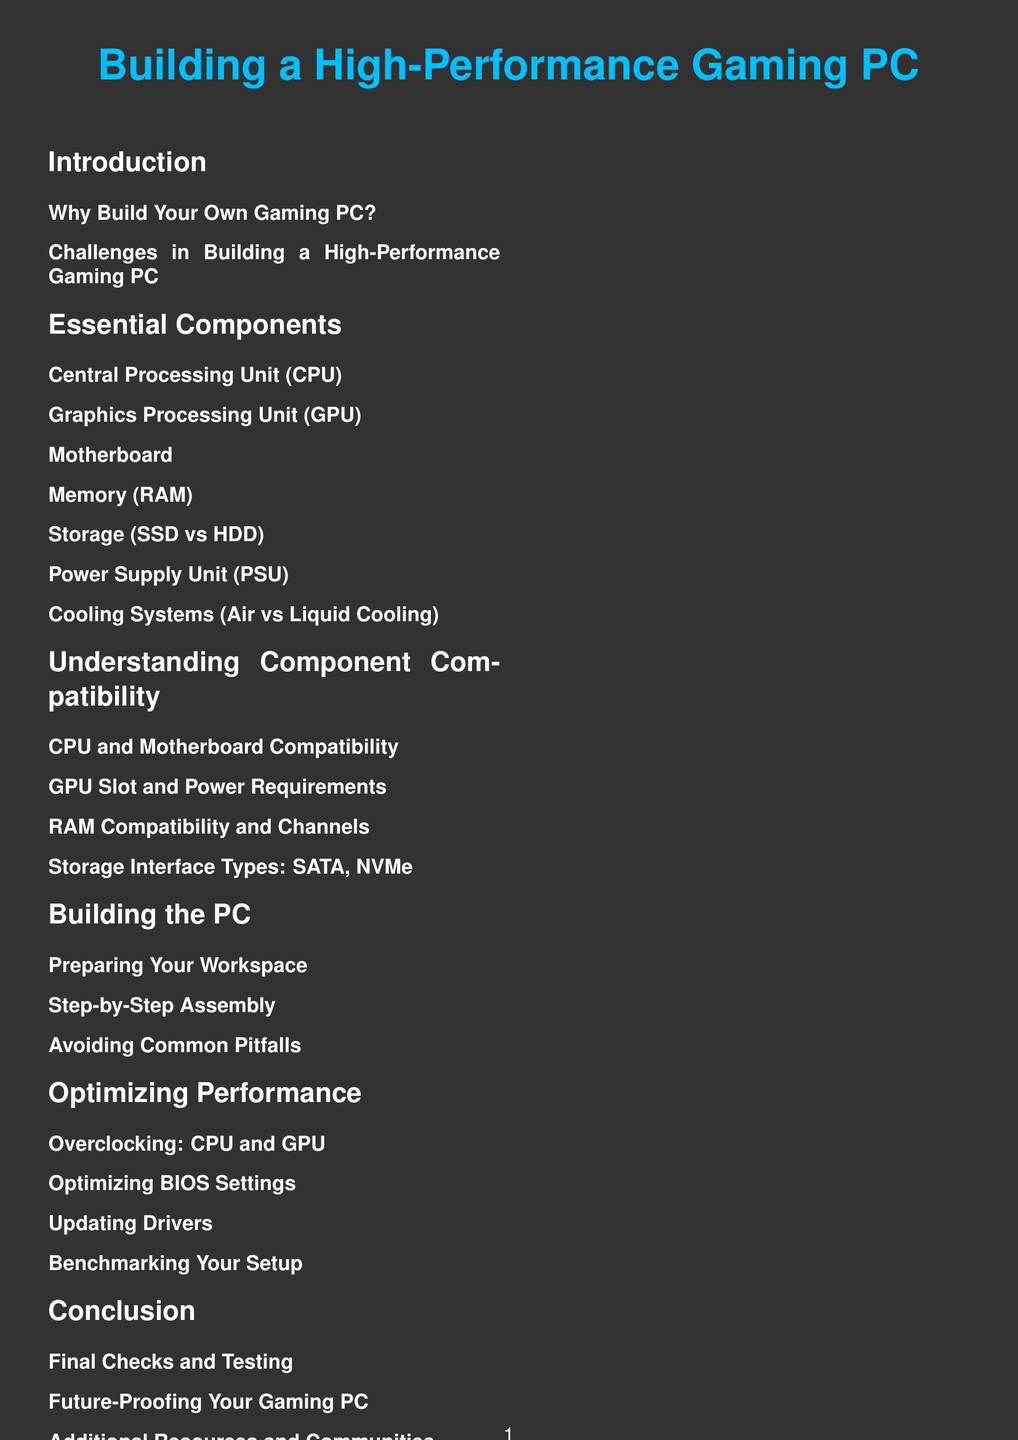What is the title of the document? The title of the document is presented prominently at the beginning and states what the document is about, which is "Building a High-Performance Gaming PC."
Answer: Building a High-Performance Gaming PC How many main sections are in the document? The document contains several main sections, which can be counted from the table of contents.
Answer: 6 What component is covered first in the Essential Components section? The first component listed under Essential Components is typically the most critical one for performance, which is the CPU.
Answer: Central Processing Unit (CPU) What are the two types of cooling systems mentioned? The document lists cooling systems under the Essential Components section, specifying two types: air and liquid cooling.
Answer: Air vs Liquid Cooling What is one challenge in building a gaming PC? This likely refers to common difficulties faced during the process, as listed in the Introduction.
Answer: Challenges in Building a High-Performance Gaming PC What is the focus of the section titled “Optimizing Performance”? This section deals with improving the gaming experience and system efficiency through various techniques such as overclocking and driver updates.
Answer: Overclocking: CPU and GPU What will you find in the Conclusion section regarding future-proofing? The conclusion emphasizes considerations for ensuring the gaming PC remains relevant and effective over time.
Answer: Future-Proofing Your Gaming PC 